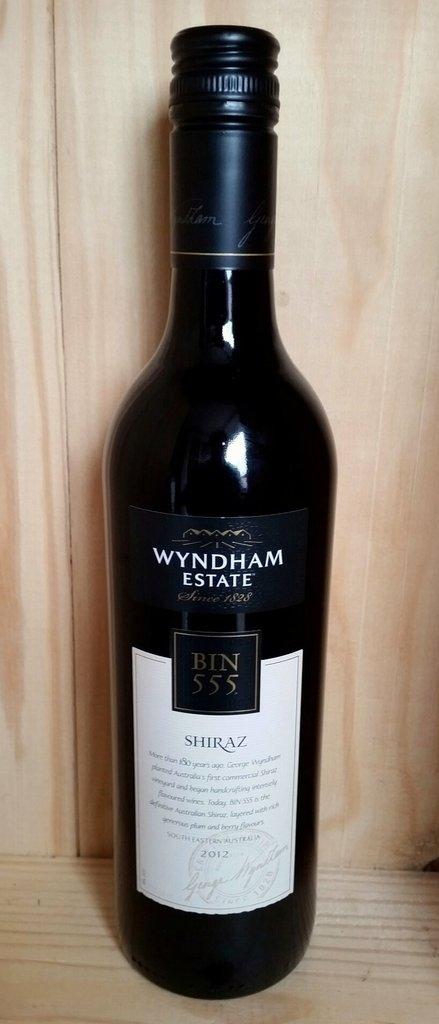What estate is this wine from?
Keep it short and to the point. Wyndham. What kind of wine is it?
Your answer should be very brief. Shiraz. 